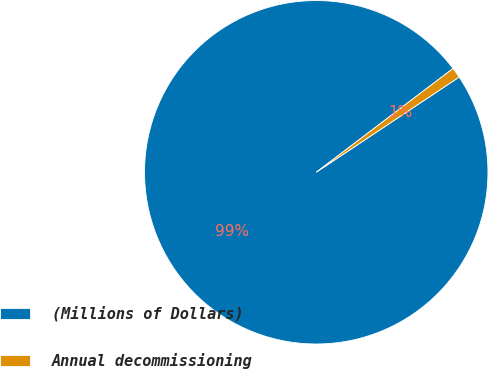<chart> <loc_0><loc_0><loc_500><loc_500><pie_chart><fcel>(Millions of Dollars)<fcel>Annual decommissioning<nl><fcel>99.02%<fcel>0.98%<nl></chart> 